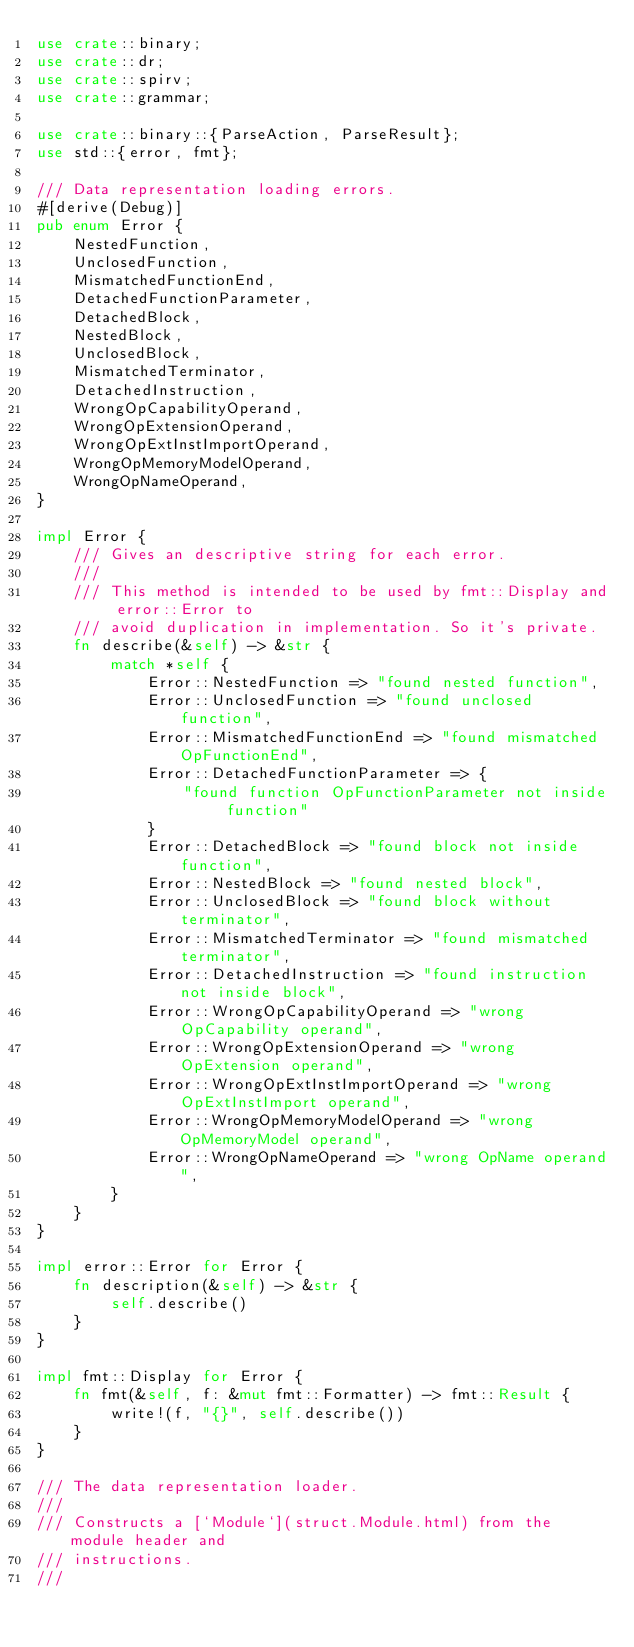Convert code to text. <code><loc_0><loc_0><loc_500><loc_500><_Rust_>use crate::binary;
use crate::dr;
use crate::spirv;
use crate::grammar;

use crate::binary::{ParseAction, ParseResult};
use std::{error, fmt};

/// Data representation loading errors.
#[derive(Debug)]
pub enum Error {
    NestedFunction,
    UnclosedFunction,
    MismatchedFunctionEnd,
    DetachedFunctionParameter,
    DetachedBlock,
    NestedBlock,
    UnclosedBlock,
    MismatchedTerminator,
    DetachedInstruction,
    WrongOpCapabilityOperand,
    WrongOpExtensionOperand,
    WrongOpExtInstImportOperand,
    WrongOpMemoryModelOperand,
    WrongOpNameOperand,
}

impl Error {
    /// Gives an descriptive string for each error.
    ///
    /// This method is intended to be used by fmt::Display and error::Error to
    /// avoid duplication in implementation. So it's private.
    fn describe(&self) -> &str {
        match *self {
            Error::NestedFunction => "found nested function",
            Error::UnclosedFunction => "found unclosed function",
            Error::MismatchedFunctionEnd => "found mismatched OpFunctionEnd",
            Error::DetachedFunctionParameter => {
                "found function OpFunctionParameter not inside function"
            }
            Error::DetachedBlock => "found block not inside function",
            Error::NestedBlock => "found nested block",
            Error::UnclosedBlock => "found block without terminator",
            Error::MismatchedTerminator => "found mismatched terminator",
            Error::DetachedInstruction => "found instruction not inside block",
            Error::WrongOpCapabilityOperand => "wrong OpCapability operand",
            Error::WrongOpExtensionOperand => "wrong OpExtension operand",
            Error::WrongOpExtInstImportOperand => "wrong OpExtInstImport operand",
            Error::WrongOpMemoryModelOperand => "wrong OpMemoryModel operand",
            Error::WrongOpNameOperand => "wrong OpName operand",
        }
    }
}

impl error::Error for Error {
    fn description(&self) -> &str {
        self.describe()
    }
}

impl fmt::Display for Error {
    fn fmt(&self, f: &mut fmt::Formatter) -> fmt::Result {
        write!(f, "{}", self.describe())
    }
}

/// The data representation loader.
///
/// Constructs a [`Module`](struct.Module.html) from the module header and
/// instructions.
///</code> 